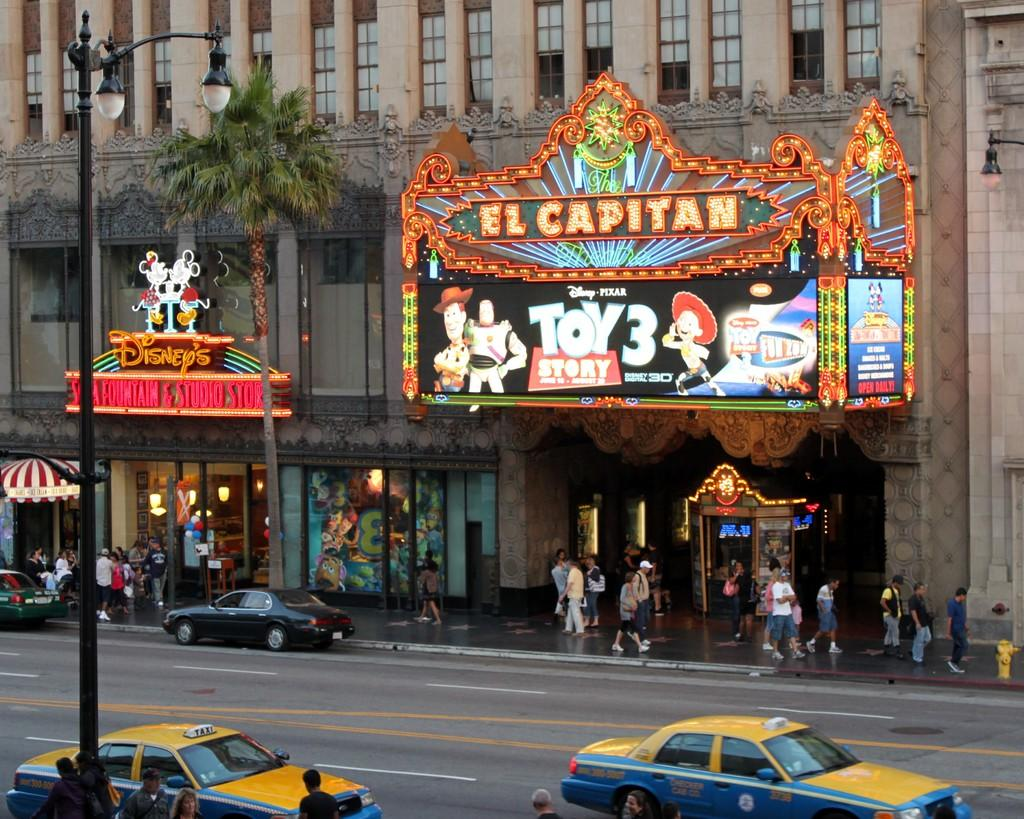<image>
Render a clear and concise summary of the photo. The front of the El Capitan theater that has toy story three featured on the billboard. 